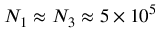<formula> <loc_0><loc_0><loc_500><loc_500>N _ { 1 } \approx N _ { 3 } \approx 5 \times 1 0 ^ { 5 }</formula> 